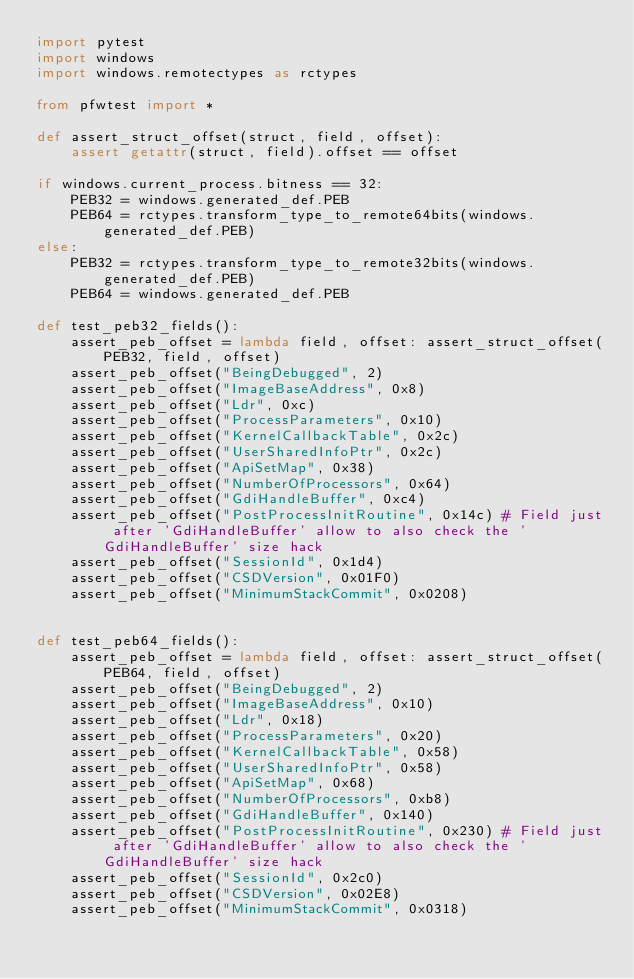Convert code to text. <code><loc_0><loc_0><loc_500><loc_500><_Python_>import pytest
import windows
import windows.remotectypes as rctypes

from pfwtest import *

def assert_struct_offset(struct, field, offset):
    assert getattr(struct, field).offset == offset

if windows.current_process.bitness == 32:
    PEB32 = windows.generated_def.PEB
    PEB64 = rctypes.transform_type_to_remote64bits(windows.generated_def.PEB)
else:
    PEB32 = rctypes.transform_type_to_remote32bits(windows.generated_def.PEB)
    PEB64 = windows.generated_def.PEB

def test_peb32_fields():
    assert_peb_offset = lambda field, offset: assert_struct_offset(PEB32, field, offset)
    assert_peb_offset("BeingDebugged", 2)
    assert_peb_offset("ImageBaseAddress", 0x8)
    assert_peb_offset("Ldr", 0xc)
    assert_peb_offset("ProcessParameters", 0x10)
    assert_peb_offset("KernelCallbackTable", 0x2c)
    assert_peb_offset("UserSharedInfoPtr", 0x2c)
    assert_peb_offset("ApiSetMap", 0x38)
    assert_peb_offset("NumberOfProcessors", 0x64)
    assert_peb_offset("GdiHandleBuffer", 0xc4)
    assert_peb_offset("PostProcessInitRoutine", 0x14c) # Field just after 'GdiHandleBuffer' allow to also check the 'GdiHandleBuffer' size hack
    assert_peb_offset("SessionId", 0x1d4)
    assert_peb_offset("CSDVersion", 0x01F0)
    assert_peb_offset("MinimumStackCommit", 0x0208)


def test_peb64_fields():
    assert_peb_offset = lambda field, offset: assert_struct_offset(PEB64, field, offset)
    assert_peb_offset("BeingDebugged", 2)
    assert_peb_offset("ImageBaseAddress", 0x10)
    assert_peb_offset("Ldr", 0x18)
    assert_peb_offset("ProcessParameters", 0x20)
    assert_peb_offset("KernelCallbackTable", 0x58)
    assert_peb_offset("UserSharedInfoPtr", 0x58)
    assert_peb_offset("ApiSetMap", 0x68)
    assert_peb_offset("NumberOfProcessors", 0xb8)
    assert_peb_offset("GdiHandleBuffer", 0x140)
    assert_peb_offset("PostProcessInitRoutine", 0x230) # Field just after 'GdiHandleBuffer' allow to also check the 'GdiHandleBuffer' size hack
    assert_peb_offset("SessionId", 0x2c0)
    assert_peb_offset("CSDVersion", 0x02E8)
    assert_peb_offset("MinimumStackCommit", 0x0318)</code> 